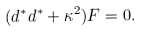Convert formula to latex. <formula><loc_0><loc_0><loc_500><loc_500>( d ^ { * } d ^ { * } + \kappa ^ { 2 } ) F = 0 .</formula> 